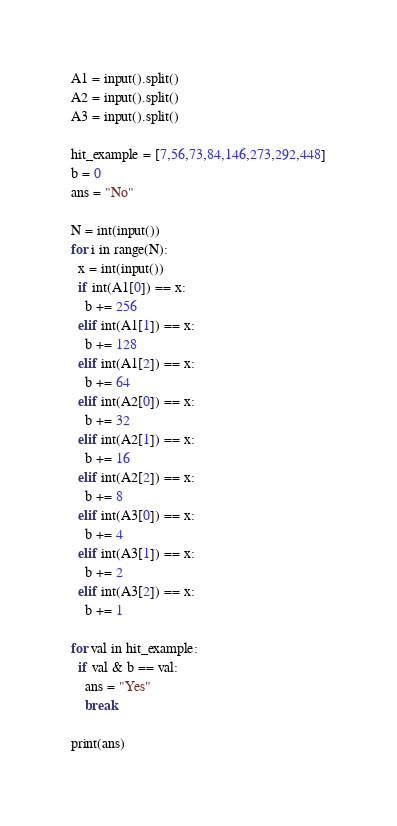<code> <loc_0><loc_0><loc_500><loc_500><_Python_>A1 = input().split()
A2 = input().split()
A3 = input().split()

hit_example = [7,56,73,84,146,273,292,448]
b = 0
ans = "No"

N = int(input())
for i in range(N):
  x = int(input())
  if int(A1[0]) == x:
    b += 256
  elif int(A1[1]) == x:
    b += 128
  elif int(A1[2]) == x:
    b += 64
  elif int(A2[0]) == x:
    b += 32
  elif int(A2[1]) == x:
    b += 16
  elif int(A2[2]) == x:
    b += 8
  elif int(A3[0]) == x:
    b += 4
  elif int(A3[1]) == x:
    b += 2
  elif int(A3[2]) == x:
    b += 1

for val in hit_example:
  if val & b == val:
    ans = "Yes"
    break
    
print(ans)</code> 